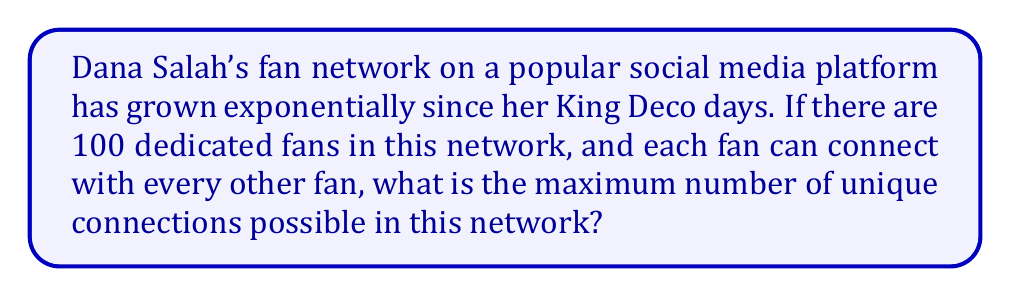Show me your answer to this math problem. To solve this problem, we need to use concepts from graph theory:

1. The fan network can be represented as an undirected complete graph, where each fan is a vertex and each connection between fans is an edge.

2. In a complete graph, every vertex is connected to every other vertex except itself.

3. The formula for the maximum number of edges in an undirected complete graph with $n$ vertices is:

   $$E = \frac{n(n-1)}{2}$$

   Where $E$ is the number of edges (connections) and $n$ is the number of vertices (fans).

4. In this case, $n = 100$ (fans).

5. Substituting into the formula:

   $$E = \frac{100(100-1)}{2} = \frac{100 \times 99}{2} = \frac{9900}{2} = 4950$$

Therefore, the maximum number of unique connections in Dana Salah's fan network of 100 people is 4950.

This can be visualized as follows:

[asy]
size(200);
int n = 10; // Using 10 points to represent 100 for simplicity
pair[] points;
for (int i = 0; i < n; ++i) {
    real angle = 2*pi*i/n;
    points.push((cos(angle), sin(angle)));
}
for (int i = 0; i < n; ++i) {
    for (int j = i+1; j < n; ++j) {
        draw(points[i]--points[j], gray(0.7));
    }
}
for (pair p : points) {
    dot(p, red);
}
label("Each dot represents 10 fans", (0,-1.3), fontsize(8));
[/asy]
Answer: 4950 connections 